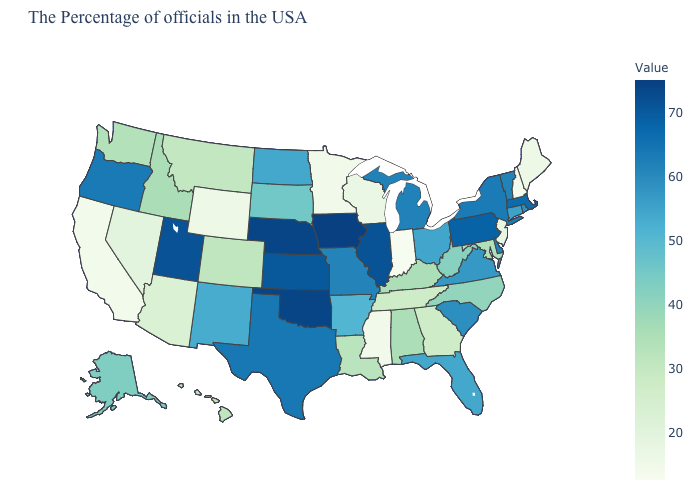Does Indiana have the lowest value in the USA?
Give a very brief answer. Yes. Among the states that border Oregon , which have the highest value?
Short answer required. Idaho. Which states have the lowest value in the MidWest?
Answer briefly. Indiana. Among the states that border Pennsylvania , which have the lowest value?
Write a very short answer. New Jersey. Which states hav the highest value in the MidWest?
Concise answer only. Iowa. Does the map have missing data?
Give a very brief answer. No. Among the states that border Colorado , which have the highest value?
Answer briefly. Nebraska, Oklahoma. 